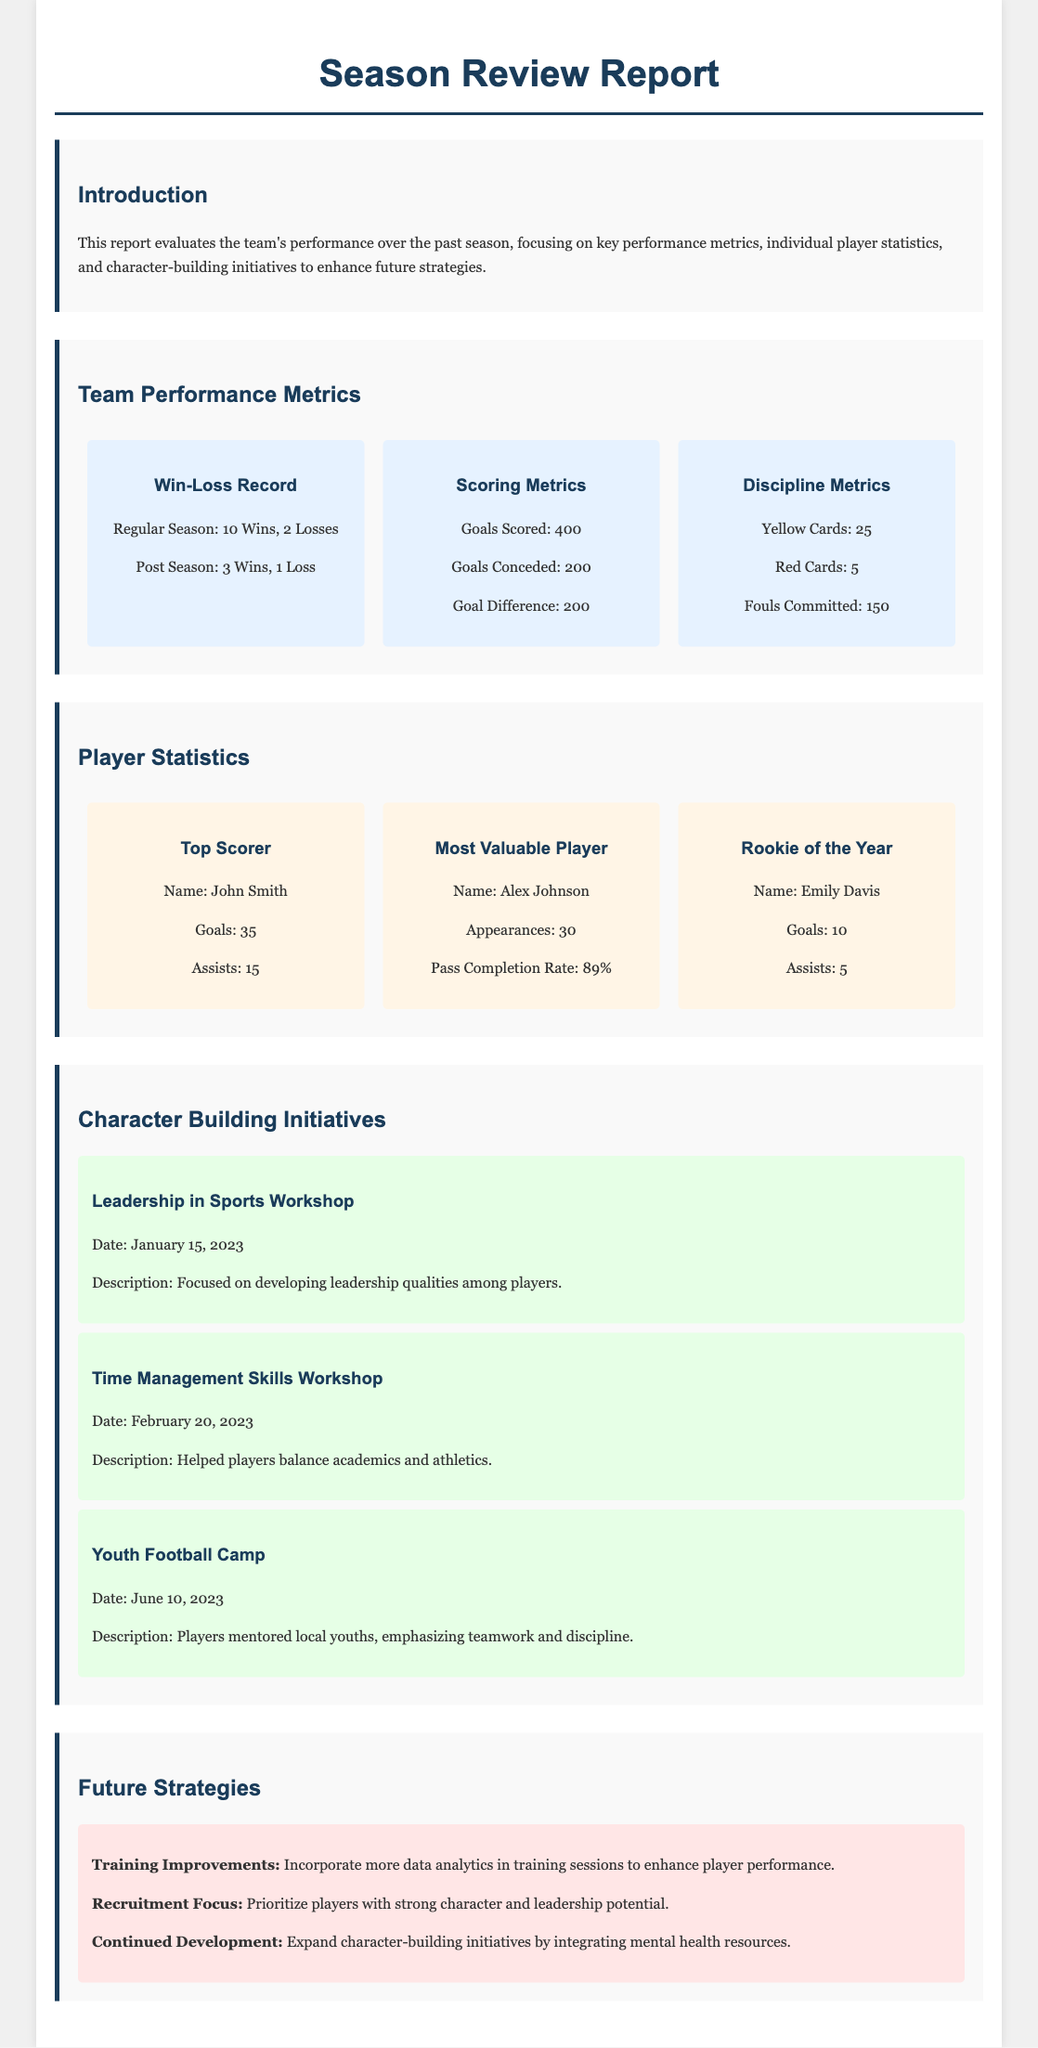What was the regular season win-loss record? The regular season win-loss record is indicated in the team performance metrics section of the document.
Answer: 10 Wins, 2 Losses Who was the top scorer of the team? The top scorer is highlighted in the player statistics section of the document.
Answer: John Smith What is the goals scored by the team? The total goals scored is present in the scoring metrics of the team performance section.
Answer: 400 What is the pass completion rate of the Most Valuable Player? This information is found in the player statistics section, specifically for the Most Valuable Player.
Answer: 89% When was the Leadership in Sports Workshop held? The date for this initiative is listed in the character-building initiatives section of the document.
Answer: January 15, 2023 What is the goal difference for the team? The goal difference is a metric listed under scoring metrics in the team performance section.
Answer: 200 What initiative focused on balancing academics and athletics? This information can be found in the character-building initiatives section of the document.
Answer: Time Management Skills Workshop What type of improvements does the future strategy recommend? The future strategies section includes recommendations for improvements in training.
Answer: Training Improvements Who was recognized as the Rookie of the Year? The Rookie of the Year is specified in the player statistics section of the report.
Answer: Emily Davis 